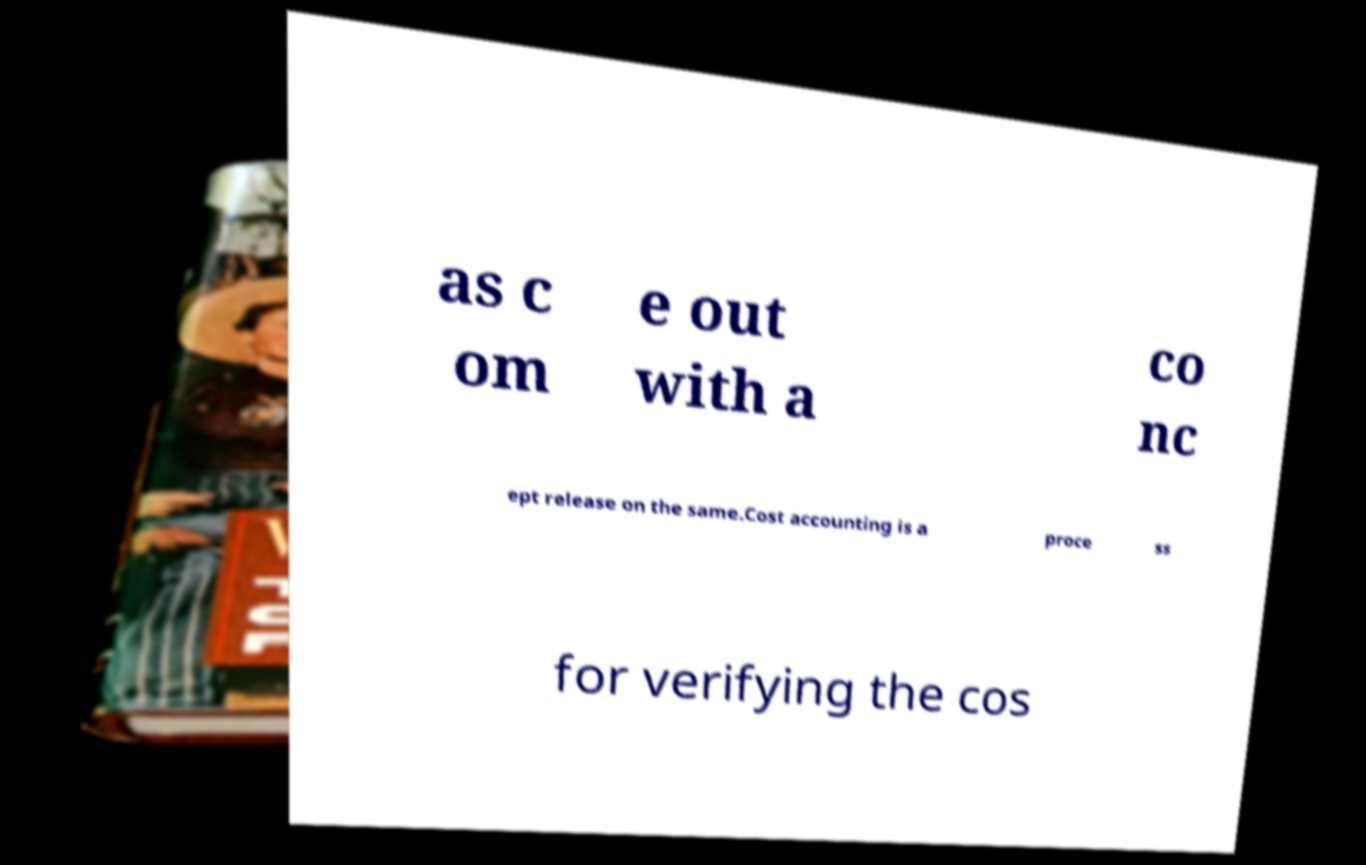I need the written content from this picture converted into text. Can you do that? as c om e out with a co nc ept release on the same.Cost accounting is a proce ss for verifying the cos 